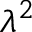<formula> <loc_0><loc_0><loc_500><loc_500>\lambda ^ { 2 }</formula> 